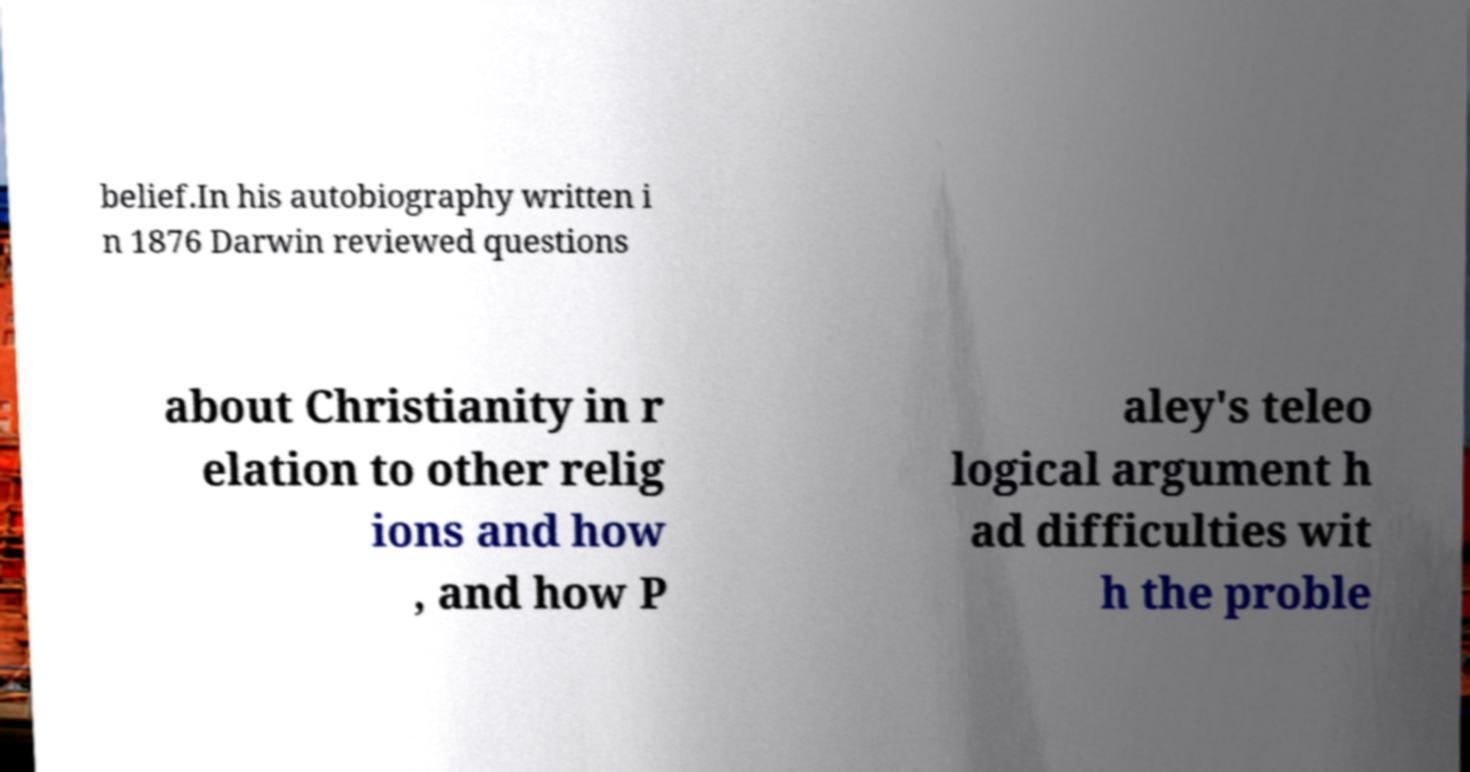What messages or text are displayed in this image? I need them in a readable, typed format. belief.In his autobiography written i n 1876 Darwin reviewed questions about Christianity in r elation to other relig ions and how , and how P aley's teleo logical argument h ad difficulties wit h the proble 